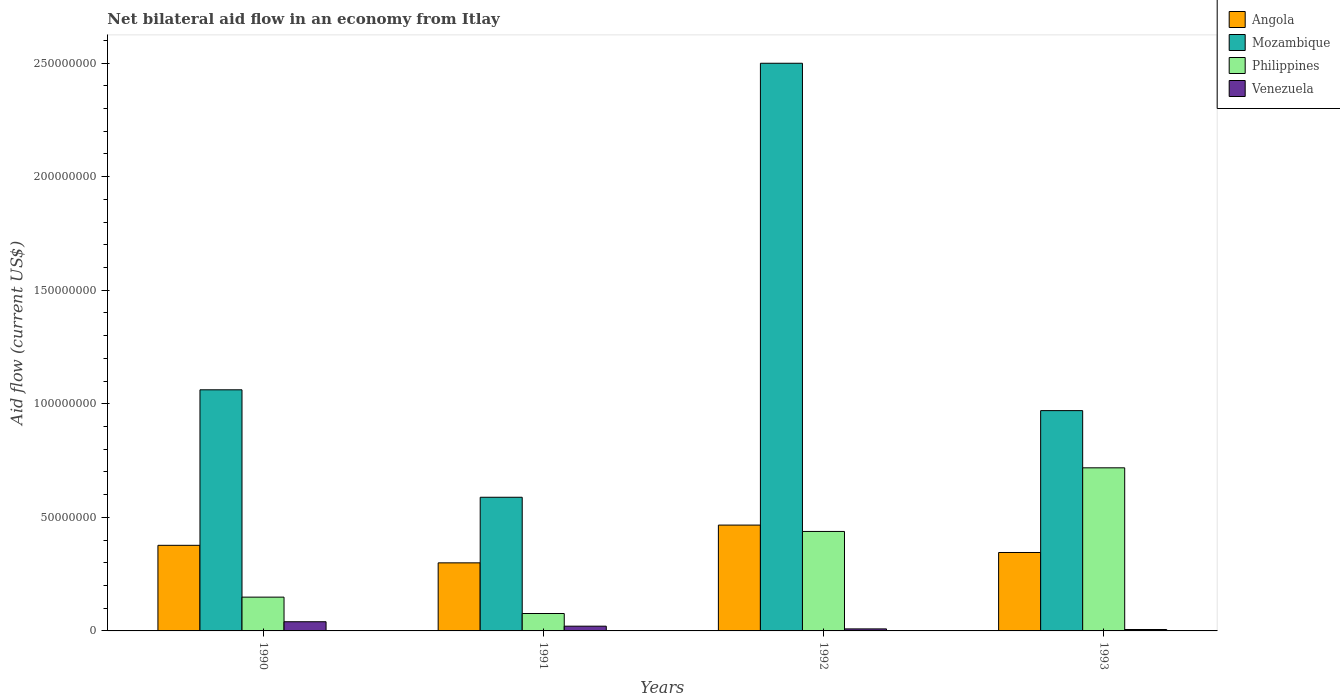Are the number of bars per tick equal to the number of legend labels?
Provide a succinct answer. Yes. Are the number of bars on each tick of the X-axis equal?
Your response must be concise. Yes. How many bars are there on the 1st tick from the left?
Your answer should be very brief. 4. What is the label of the 2nd group of bars from the left?
Your answer should be compact. 1991. What is the net bilateral aid flow in Venezuela in 1993?
Give a very brief answer. 6.20e+05. Across all years, what is the maximum net bilateral aid flow in Venezuela?
Your answer should be very brief. 4.04e+06. Across all years, what is the minimum net bilateral aid flow in Angola?
Offer a terse response. 3.00e+07. What is the total net bilateral aid flow in Venezuela in the graph?
Ensure brevity in your answer.  7.64e+06. What is the difference between the net bilateral aid flow in Philippines in 1992 and that in 1993?
Ensure brevity in your answer.  -2.80e+07. What is the difference between the net bilateral aid flow in Philippines in 1993 and the net bilateral aid flow in Angola in 1990?
Keep it short and to the point. 3.41e+07. What is the average net bilateral aid flow in Mozambique per year?
Offer a terse response. 1.28e+08. In the year 1993, what is the difference between the net bilateral aid flow in Venezuela and net bilateral aid flow in Philippines?
Offer a terse response. -7.12e+07. What is the ratio of the net bilateral aid flow in Mozambique in 1990 to that in 1993?
Your response must be concise. 1.09. Is the net bilateral aid flow in Mozambique in 1990 less than that in 1992?
Provide a succinct answer. Yes. Is the difference between the net bilateral aid flow in Venezuela in 1990 and 1993 greater than the difference between the net bilateral aid flow in Philippines in 1990 and 1993?
Your answer should be very brief. Yes. What is the difference between the highest and the second highest net bilateral aid flow in Venezuela?
Give a very brief answer. 1.95e+06. What is the difference between the highest and the lowest net bilateral aid flow in Venezuela?
Give a very brief answer. 3.42e+06. In how many years, is the net bilateral aid flow in Angola greater than the average net bilateral aid flow in Angola taken over all years?
Keep it short and to the point. 2. Is the sum of the net bilateral aid flow in Philippines in 1990 and 1991 greater than the maximum net bilateral aid flow in Angola across all years?
Ensure brevity in your answer.  No. Is it the case that in every year, the sum of the net bilateral aid flow in Venezuela and net bilateral aid flow in Philippines is greater than the sum of net bilateral aid flow in Mozambique and net bilateral aid flow in Angola?
Keep it short and to the point. No. What does the 4th bar from the left in 1991 represents?
Ensure brevity in your answer.  Venezuela. What does the 3rd bar from the right in 1991 represents?
Your response must be concise. Mozambique. Is it the case that in every year, the sum of the net bilateral aid flow in Angola and net bilateral aid flow in Mozambique is greater than the net bilateral aid flow in Venezuela?
Your response must be concise. Yes. How many bars are there?
Your answer should be very brief. 16. Are all the bars in the graph horizontal?
Offer a terse response. No. Does the graph contain any zero values?
Make the answer very short. No. Where does the legend appear in the graph?
Give a very brief answer. Top right. How many legend labels are there?
Ensure brevity in your answer.  4. How are the legend labels stacked?
Offer a very short reply. Vertical. What is the title of the graph?
Ensure brevity in your answer.  Net bilateral aid flow in an economy from Itlay. What is the label or title of the X-axis?
Give a very brief answer. Years. What is the Aid flow (current US$) of Angola in 1990?
Give a very brief answer. 3.77e+07. What is the Aid flow (current US$) in Mozambique in 1990?
Provide a succinct answer. 1.06e+08. What is the Aid flow (current US$) of Philippines in 1990?
Ensure brevity in your answer.  1.49e+07. What is the Aid flow (current US$) in Venezuela in 1990?
Give a very brief answer. 4.04e+06. What is the Aid flow (current US$) of Angola in 1991?
Offer a terse response. 3.00e+07. What is the Aid flow (current US$) of Mozambique in 1991?
Offer a very short reply. 5.88e+07. What is the Aid flow (current US$) in Philippines in 1991?
Your response must be concise. 7.67e+06. What is the Aid flow (current US$) of Venezuela in 1991?
Ensure brevity in your answer.  2.09e+06. What is the Aid flow (current US$) of Angola in 1992?
Make the answer very short. 4.66e+07. What is the Aid flow (current US$) in Mozambique in 1992?
Offer a terse response. 2.50e+08. What is the Aid flow (current US$) of Philippines in 1992?
Your answer should be compact. 4.38e+07. What is the Aid flow (current US$) of Venezuela in 1992?
Provide a short and direct response. 8.90e+05. What is the Aid flow (current US$) of Angola in 1993?
Keep it short and to the point. 3.45e+07. What is the Aid flow (current US$) of Mozambique in 1993?
Ensure brevity in your answer.  9.70e+07. What is the Aid flow (current US$) of Philippines in 1993?
Offer a very short reply. 7.18e+07. What is the Aid flow (current US$) of Venezuela in 1993?
Provide a succinct answer. 6.20e+05. Across all years, what is the maximum Aid flow (current US$) in Angola?
Your response must be concise. 4.66e+07. Across all years, what is the maximum Aid flow (current US$) of Mozambique?
Your response must be concise. 2.50e+08. Across all years, what is the maximum Aid flow (current US$) of Philippines?
Offer a very short reply. 7.18e+07. Across all years, what is the maximum Aid flow (current US$) in Venezuela?
Offer a very short reply. 4.04e+06. Across all years, what is the minimum Aid flow (current US$) of Angola?
Give a very brief answer. 3.00e+07. Across all years, what is the minimum Aid flow (current US$) in Mozambique?
Offer a very short reply. 5.88e+07. Across all years, what is the minimum Aid flow (current US$) in Philippines?
Your answer should be very brief. 7.67e+06. Across all years, what is the minimum Aid flow (current US$) of Venezuela?
Your response must be concise. 6.20e+05. What is the total Aid flow (current US$) in Angola in the graph?
Your answer should be very brief. 1.49e+08. What is the total Aid flow (current US$) of Mozambique in the graph?
Your response must be concise. 5.12e+08. What is the total Aid flow (current US$) in Philippines in the graph?
Keep it short and to the point. 1.38e+08. What is the total Aid flow (current US$) in Venezuela in the graph?
Provide a succinct answer. 7.64e+06. What is the difference between the Aid flow (current US$) in Angola in 1990 and that in 1991?
Ensure brevity in your answer.  7.72e+06. What is the difference between the Aid flow (current US$) of Mozambique in 1990 and that in 1991?
Your answer should be compact. 4.73e+07. What is the difference between the Aid flow (current US$) of Philippines in 1990 and that in 1991?
Make the answer very short. 7.21e+06. What is the difference between the Aid flow (current US$) of Venezuela in 1990 and that in 1991?
Ensure brevity in your answer.  1.95e+06. What is the difference between the Aid flow (current US$) in Angola in 1990 and that in 1992?
Offer a very short reply. -8.91e+06. What is the difference between the Aid flow (current US$) of Mozambique in 1990 and that in 1992?
Give a very brief answer. -1.44e+08. What is the difference between the Aid flow (current US$) in Philippines in 1990 and that in 1992?
Your answer should be very brief. -2.89e+07. What is the difference between the Aid flow (current US$) of Venezuela in 1990 and that in 1992?
Offer a terse response. 3.15e+06. What is the difference between the Aid flow (current US$) in Angola in 1990 and that in 1993?
Ensure brevity in your answer.  3.16e+06. What is the difference between the Aid flow (current US$) in Mozambique in 1990 and that in 1993?
Provide a succinct answer. 9.16e+06. What is the difference between the Aid flow (current US$) of Philippines in 1990 and that in 1993?
Provide a short and direct response. -5.69e+07. What is the difference between the Aid flow (current US$) of Venezuela in 1990 and that in 1993?
Keep it short and to the point. 3.42e+06. What is the difference between the Aid flow (current US$) in Angola in 1991 and that in 1992?
Provide a succinct answer. -1.66e+07. What is the difference between the Aid flow (current US$) of Mozambique in 1991 and that in 1992?
Make the answer very short. -1.91e+08. What is the difference between the Aid flow (current US$) in Philippines in 1991 and that in 1992?
Make the answer very short. -3.61e+07. What is the difference between the Aid flow (current US$) of Venezuela in 1991 and that in 1992?
Your answer should be very brief. 1.20e+06. What is the difference between the Aid flow (current US$) of Angola in 1991 and that in 1993?
Make the answer very short. -4.56e+06. What is the difference between the Aid flow (current US$) in Mozambique in 1991 and that in 1993?
Offer a terse response. -3.82e+07. What is the difference between the Aid flow (current US$) in Philippines in 1991 and that in 1993?
Keep it short and to the point. -6.41e+07. What is the difference between the Aid flow (current US$) of Venezuela in 1991 and that in 1993?
Provide a succinct answer. 1.47e+06. What is the difference between the Aid flow (current US$) of Angola in 1992 and that in 1993?
Offer a terse response. 1.21e+07. What is the difference between the Aid flow (current US$) of Mozambique in 1992 and that in 1993?
Give a very brief answer. 1.53e+08. What is the difference between the Aid flow (current US$) in Philippines in 1992 and that in 1993?
Your response must be concise. -2.80e+07. What is the difference between the Aid flow (current US$) in Angola in 1990 and the Aid flow (current US$) in Mozambique in 1991?
Ensure brevity in your answer.  -2.12e+07. What is the difference between the Aid flow (current US$) of Angola in 1990 and the Aid flow (current US$) of Philippines in 1991?
Your answer should be very brief. 3.00e+07. What is the difference between the Aid flow (current US$) of Angola in 1990 and the Aid flow (current US$) of Venezuela in 1991?
Offer a terse response. 3.56e+07. What is the difference between the Aid flow (current US$) of Mozambique in 1990 and the Aid flow (current US$) of Philippines in 1991?
Your answer should be compact. 9.85e+07. What is the difference between the Aid flow (current US$) of Mozambique in 1990 and the Aid flow (current US$) of Venezuela in 1991?
Give a very brief answer. 1.04e+08. What is the difference between the Aid flow (current US$) of Philippines in 1990 and the Aid flow (current US$) of Venezuela in 1991?
Your answer should be very brief. 1.28e+07. What is the difference between the Aid flow (current US$) of Angola in 1990 and the Aid flow (current US$) of Mozambique in 1992?
Provide a succinct answer. -2.12e+08. What is the difference between the Aid flow (current US$) in Angola in 1990 and the Aid flow (current US$) in Philippines in 1992?
Ensure brevity in your answer.  -6.11e+06. What is the difference between the Aid flow (current US$) of Angola in 1990 and the Aid flow (current US$) of Venezuela in 1992?
Give a very brief answer. 3.68e+07. What is the difference between the Aid flow (current US$) in Mozambique in 1990 and the Aid flow (current US$) in Philippines in 1992?
Offer a very short reply. 6.24e+07. What is the difference between the Aid flow (current US$) in Mozambique in 1990 and the Aid flow (current US$) in Venezuela in 1992?
Offer a terse response. 1.05e+08. What is the difference between the Aid flow (current US$) in Philippines in 1990 and the Aid flow (current US$) in Venezuela in 1992?
Provide a succinct answer. 1.40e+07. What is the difference between the Aid flow (current US$) of Angola in 1990 and the Aid flow (current US$) of Mozambique in 1993?
Your answer should be compact. -5.93e+07. What is the difference between the Aid flow (current US$) of Angola in 1990 and the Aid flow (current US$) of Philippines in 1993?
Keep it short and to the point. -3.41e+07. What is the difference between the Aid flow (current US$) in Angola in 1990 and the Aid flow (current US$) in Venezuela in 1993?
Make the answer very short. 3.71e+07. What is the difference between the Aid flow (current US$) in Mozambique in 1990 and the Aid flow (current US$) in Philippines in 1993?
Ensure brevity in your answer.  3.44e+07. What is the difference between the Aid flow (current US$) of Mozambique in 1990 and the Aid flow (current US$) of Venezuela in 1993?
Offer a very short reply. 1.06e+08. What is the difference between the Aid flow (current US$) in Philippines in 1990 and the Aid flow (current US$) in Venezuela in 1993?
Offer a very short reply. 1.43e+07. What is the difference between the Aid flow (current US$) of Angola in 1991 and the Aid flow (current US$) of Mozambique in 1992?
Provide a succinct answer. -2.20e+08. What is the difference between the Aid flow (current US$) in Angola in 1991 and the Aid flow (current US$) in Philippines in 1992?
Offer a very short reply. -1.38e+07. What is the difference between the Aid flow (current US$) in Angola in 1991 and the Aid flow (current US$) in Venezuela in 1992?
Your response must be concise. 2.91e+07. What is the difference between the Aid flow (current US$) in Mozambique in 1991 and the Aid flow (current US$) in Philippines in 1992?
Ensure brevity in your answer.  1.50e+07. What is the difference between the Aid flow (current US$) of Mozambique in 1991 and the Aid flow (current US$) of Venezuela in 1992?
Give a very brief answer. 5.80e+07. What is the difference between the Aid flow (current US$) in Philippines in 1991 and the Aid flow (current US$) in Venezuela in 1992?
Ensure brevity in your answer.  6.78e+06. What is the difference between the Aid flow (current US$) in Angola in 1991 and the Aid flow (current US$) in Mozambique in 1993?
Give a very brief answer. -6.70e+07. What is the difference between the Aid flow (current US$) in Angola in 1991 and the Aid flow (current US$) in Philippines in 1993?
Offer a terse response. -4.18e+07. What is the difference between the Aid flow (current US$) in Angola in 1991 and the Aid flow (current US$) in Venezuela in 1993?
Keep it short and to the point. 2.94e+07. What is the difference between the Aid flow (current US$) in Mozambique in 1991 and the Aid flow (current US$) in Philippines in 1993?
Offer a very short reply. -1.30e+07. What is the difference between the Aid flow (current US$) in Mozambique in 1991 and the Aid flow (current US$) in Venezuela in 1993?
Your response must be concise. 5.82e+07. What is the difference between the Aid flow (current US$) in Philippines in 1991 and the Aid flow (current US$) in Venezuela in 1993?
Provide a succinct answer. 7.05e+06. What is the difference between the Aid flow (current US$) of Angola in 1992 and the Aid flow (current US$) of Mozambique in 1993?
Offer a very short reply. -5.04e+07. What is the difference between the Aid flow (current US$) in Angola in 1992 and the Aid flow (current US$) in Philippines in 1993?
Your answer should be compact. -2.52e+07. What is the difference between the Aid flow (current US$) of Angola in 1992 and the Aid flow (current US$) of Venezuela in 1993?
Ensure brevity in your answer.  4.60e+07. What is the difference between the Aid flow (current US$) of Mozambique in 1992 and the Aid flow (current US$) of Philippines in 1993?
Your answer should be compact. 1.78e+08. What is the difference between the Aid flow (current US$) of Mozambique in 1992 and the Aid flow (current US$) of Venezuela in 1993?
Keep it short and to the point. 2.49e+08. What is the difference between the Aid flow (current US$) of Philippines in 1992 and the Aid flow (current US$) of Venezuela in 1993?
Provide a short and direct response. 4.32e+07. What is the average Aid flow (current US$) in Angola per year?
Ensure brevity in your answer.  3.72e+07. What is the average Aid flow (current US$) of Mozambique per year?
Give a very brief answer. 1.28e+08. What is the average Aid flow (current US$) of Philippines per year?
Your response must be concise. 3.45e+07. What is the average Aid flow (current US$) of Venezuela per year?
Provide a succinct answer. 1.91e+06. In the year 1990, what is the difference between the Aid flow (current US$) of Angola and Aid flow (current US$) of Mozambique?
Offer a very short reply. -6.85e+07. In the year 1990, what is the difference between the Aid flow (current US$) of Angola and Aid flow (current US$) of Philippines?
Make the answer very short. 2.28e+07. In the year 1990, what is the difference between the Aid flow (current US$) of Angola and Aid flow (current US$) of Venezuela?
Your answer should be compact. 3.36e+07. In the year 1990, what is the difference between the Aid flow (current US$) in Mozambique and Aid flow (current US$) in Philippines?
Make the answer very short. 9.13e+07. In the year 1990, what is the difference between the Aid flow (current US$) in Mozambique and Aid flow (current US$) in Venezuela?
Provide a short and direct response. 1.02e+08. In the year 1990, what is the difference between the Aid flow (current US$) in Philippines and Aid flow (current US$) in Venezuela?
Ensure brevity in your answer.  1.08e+07. In the year 1991, what is the difference between the Aid flow (current US$) in Angola and Aid flow (current US$) in Mozambique?
Make the answer very short. -2.89e+07. In the year 1991, what is the difference between the Aid flow (current US$) in Angola and Aid flow (current US$) in Philippines?
Ensure brevity in your answer.  2.23e+07. In the year 1991, what is the difference between the Aid flow (current US$) of Angola and Aid flow (current US$) of Venezuela?
Provide a succinct answer. 2.79e+07. In the year 1991, what is the difference between the Aid flow (current US$) in Mozambique and Aid flow (current US$) in Philippines?
Offer a very short reply. 5.12e+07. In the year 1991, what is the difference between the Aid flow (current US$) of Mozambique and Aid flow (current US$) of Venezuela?
Keep it short and to the point. 5.68e+07. In the year 1991, what is the difference between the Aid flow (current US$) of Philippines and Aid flow (current US$) of Venezuela?
Give a very brief answer. 5.58e+06. In the year 1992, what is the difference between the Aid flow (current US$) in Angola and Aid flow (current US$) in Mozambique?
Ensure brevity in your answer.  -2.03e+08. In the year 1992, what is the difference between the Aid flow (current US$) in Angola and Aid flow (current US$) in Philippines?
Provide a succinct answer. 2.80e+06. In the year 1992, what is the difference between the Aid flow (current US$) of Angola and Aid flow (current US$) of Venezuela?
Ensure brevity in your answer.  4.57e+07. In the year 1992, what is the difference between the Aid flow (current US$) in Mozambique and Aid flow (current US$) in Philippines?
Your answer should be very brief. 2.06e+08. In the year 1992, what is the difference between the Aid flow (current US$) in Mozambique and Aid flow (current US$) in Venezuela?
Keep it short and to the point. 2.49e+08. In the year 1992, what is the difference between the Aid flow (current US$) in Philippines and Aid flow (current US$) in Venezuela?
Your response must be concise. 4.29e+07. In the year 1993, what is the difference between the Aid flow (current US$) in Angola and Aid flow (current US$) in Mozambique?
Offer a terse response. -6.25e+07. In the year 1993, what is the difference between the Aid flow (current US$) of Angola and Aid flow (current US$) of Philippines?
Offer a terse response. -3.73e+07. In the year 1993, what is the difference between the Aid flow (current US$) of Angola and Aid flow (current US$) of Venezuela?
Keep it short and to the point. 3.39e+07. In the year 1993, what is the difference between the Aid flow (current US$) of Mozambique and Aid flow (current US$) of Philippines?
Offer a terse response. 2.52e+07. In the year 1993, what is the difference between the Aid flow (current US$) of Mozambique and Aid flow (current US$) of Venezuela?
Offer a very short reply. 9.64e+07. In the year 1993, what is the difference between the Aid flow (current US$) of Philippines and Aid flow (current US$) of Venezuela?
Give a very brief answer. 7.12e+07. What is the ratio of the Aid flow (current US$) in Angola in 1990 to that in 1991?
Provide a short and direct response. 1.26. What is the ratio of the Aid flow (current US$) in Mozambique in 1990 to that in 1991?
Provide a succinct answer. 1.8. What is the ratio of the Aid flow (current US$) of Philippines in 1990 to that in 1991?
Keep it short and to the point. 1.94. What is the ratio of the Aid flow (current US$) of Venezuela in 1990 to that in 1991?
Your response must be concise. 1.93. What is the ratio of the Aid flow (current US$) in Angola in 1990 to that in 1992?
Your response must be concise. 0.81. What is the ratio of the Aid flow (current US$) of Mozambique in 1990 to that in 1992?
Keep it short and to the point. 0.42. What is the ratio of the Aid flow (current US$) in Philippines in 1990 to that in 1992?
Ensure brevity in your answer.  0.34. What is the ratio of the Aid flow (current US$) in Venezuela in 1990 to that in 1992?
Offer a very short reply. 4.54. What is the ratio of the Aid flow (current US$) in Angola in 1990 to that in 1993?
Keep it short and to the point. 1.09. What is the ratio of the Aid flow (current US$) of Mozambique in 1990 to that in 1993?
Your answer should be compact. 1.09. What is the ratio of the Aid flow (current US$) in Philippines in 1990 to that in 1993?
Make the answer very short. 0.21. What is the ratio of the Aid flow (current US$) in Venezuela in 1990 to that in 1993?
Make the answer very short. 6.52. What is the ratio of the Aid flow (current US$) in Angola in 1991 to that in 1992?
Your response must be concise. 0.64. What is the ratio of the Aid flow (current US$) in Mozambique in 1991 to that in 1992?
Keep it short and to the point. 0.24. What is the ratio of the Aid flow (current US$) of Philippines in 1991 to that in 1992?
Ensure brevity in your answer.  0.18. What is the ratio of the Aid flow (current US$) in Venezuela in 1991 to that in 1992?
Provide a succinct answer. 2.35. What is the ratio of the Aid flow (current US$) in Angola in 1991 to that in 1993?
Provide a succinct answer. 0.87. What is the ratio of the Aid flow (current US$) of Mozambique in 1991 to that in 1993?
Ensure brevity in your answer.  0.61. What is the ratio of the Aid flow (current US$) of Philippines in 1991 to that in 1993?
Offer a very short reply. 0.11. What is the ratio of the Aid flow (current US$) in Venezuela in 1991 to that in 1993?
Your answer should be compact. 3.37. What is the ratio of the Aid flow (current US$) of Angola in 1992 to that in 1993?
Offer a terse response. 1.35. What is the ratio of the Aid flow (current US$) in Mozambique in 1992 to that in 1993?
Your answer should be very brief. 2.58. What is the ratio of the Aid flow (current US$) of Philippines in 1992 to that in 1993?
Provide a succinct answer. 0.61. What is the ratio of the Aid flow (current US$) of Venezuela in 1992 to that in 1993?
Keep it short and to the point. 1.44. What is the difference between the highest and the second highest Aid flow (current US$) of Angola?
Provide a short and direct response. 8.91e+06. What is the difference between the highest and the second highest Aid flow (current US$) in Mozambique?
Give a very brief answer. 1.44e+08. What is the difference between the highest and the second highest Aid flow (current US$) of Philippines?
Provide a succinct answer. 2.80e+07. What is the difference between the highest and the second highest Aid flow (current US$) in Venezuela?
Offer a very short reply. 1.95e+06. What is the difference between the highest and the lowest Aid flow (current US$) in Angola?
Offer a very short reply. 1.66e+07. What is the difference between the highest and the lowest Aid flow (current US$) of Mozambique?
Give a very brief answer. 1.91e+08. What is the difference between the highest and the lowest Aid flow (current US$) in Philippines?
Keep it short and to the point. 6.41e+07. What is the difference between the highest and the lowest Aid flow (current US$) in Venezuela?
Ensure brevity in your answer.  3.42e+06. 